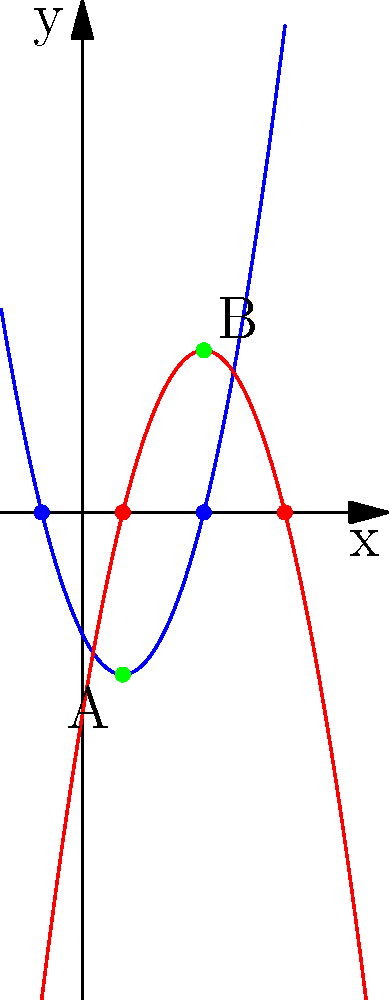In the graph above, two parabolas are shown: $y = x^2 - 2x - 3$ (blue) and $y = -x^2 + 6x - 5$ (red). These parabolas intersect at two points, labeled A and B. What is the sum of the x-coordinates of these intersection points? Let's approach this step-by-step:

1) To find the intersection points, we need to solve the equation:
   $x^2 - 2x - 3 = -x^2 + 6x - 5$

2) Rearranging the terms:
   $2x^2 - 8x + 2 = 0$

3) Divide all terms by 2:
   $x^2 - 4x + 1 = 0$

4) This is a quadratic equation. We can solve it using the quadratic formula:
   $x = \frac{-b \pm \sqrt{b^2 - 4ac}}{2a}$

   Where $a=1$, $b=-4$, and $c=1$

5) Plugging these values into the formula:
   $x = \frac{4 \pm \sqrt{16 - 4}}{2} = \frac{4 \pm \sqrt{12}}{2} = \frac{4 \pm 2\sqrt{3}}{2}$

6) This gives us two solutions:
   $x_1 = \frac{4 + 2\sqrt{3}}{2} = 2 + \sqrt{3}$
   $x_2 = \frac{4 - 2\sqrt{3}}{2} = 2 - \sqrt{3}$

7) The sum of these x-coordinates is:
   $(2 + \sqrt{3}) + (2 - \sqrt{3}) = 4$

Thus, the sum of the x-coordinates of the intersection points is 4.
Answer: 4 